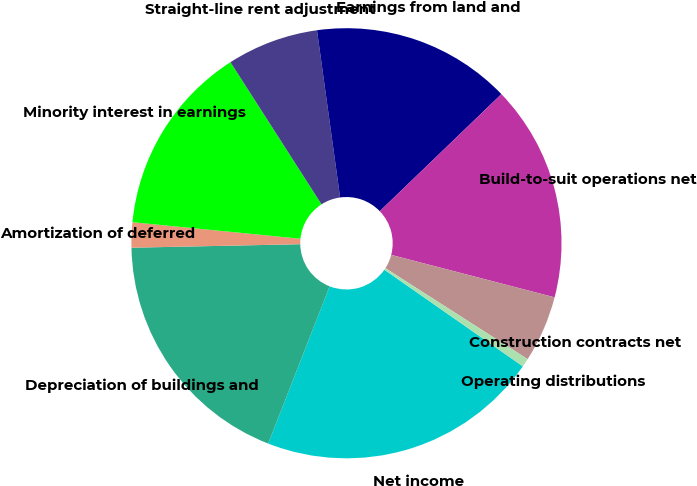Convert chart to OTSL. <chart><loc_0><loc_0><loc_500><loc_500><pie_chart><fcel>Net income<fcel>Depreciation of buildings and<fcel>Amortization of deferred<fcel>Minority interest in earnings<fcel>Straight-line rent adjustment<fcel>Earnings from land and<fcel>Build-to-suit operations net<fcel>Construction contracts net<fcel>Operating distributions<nl><fcel>21.23%<fcel>18.74%<fcel>1.89%<fcel>14.37%<fcel>6.88%<fcel>14.99%<fcel>16.24%<fcel>5.01%<fcel>0.64%<nl></chart> 